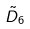Convert formula to latex. <formula><loc_0><loc_0><loc_500><loc_500>\tilde { D } _ { 6 }</formula> 